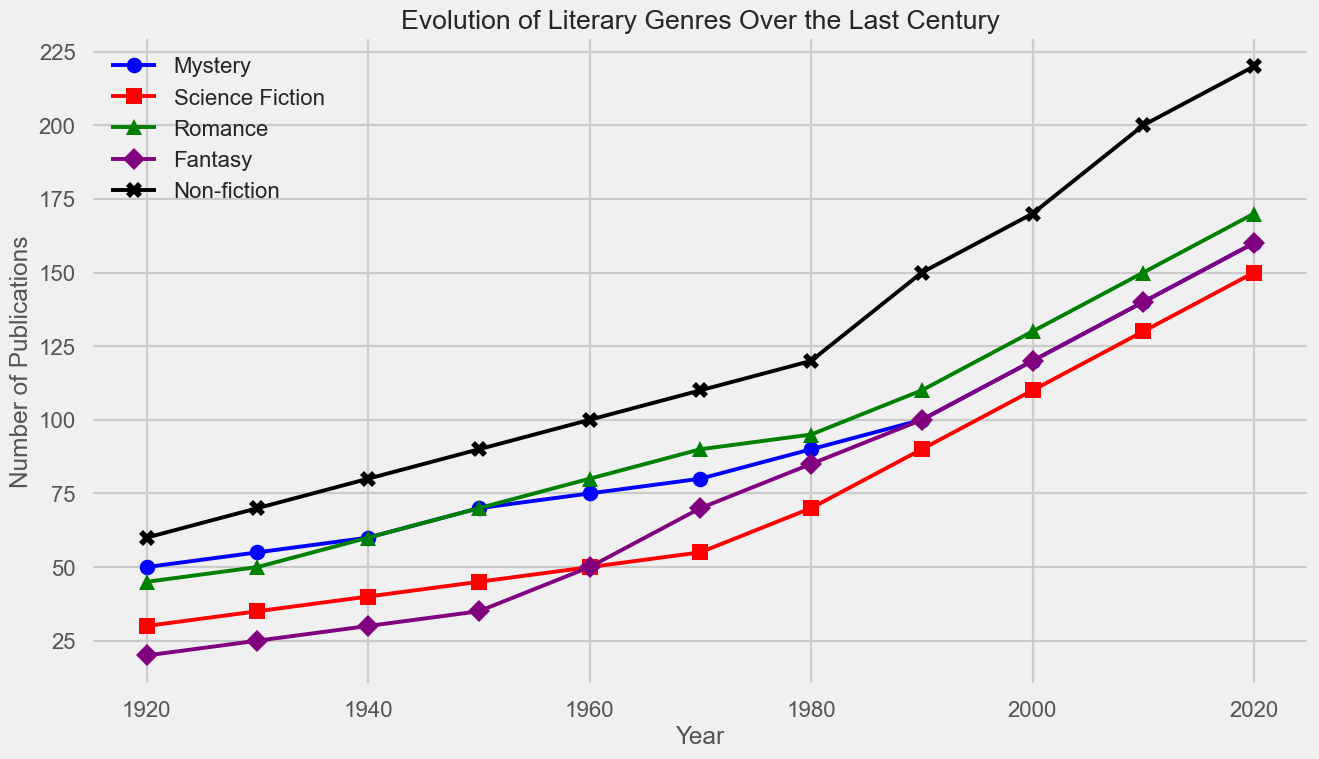what is the overall trend of Romance publications over the years? The green line with triangle markers representing Romance shows a steady increase from 45 publications in 1920 to 170 publications in 2020. This indicates a consistent growth in Romance publications over the century.
Answer: Steady increase Which genre had the highest number of publications in 1940 and how many were there? By observing the year 1940 on the x-axis and comparing the heights of the lines, Non-fiction had the highest number of publications at 80.
Answer: Non-fiction, 80 How did the publications for Science Fiction in 1950 compare to those in 1970? Science Fiction, represented by the red line with square markers, had 45 publications in 1950 and 55 in 1970. The publications increased by 10 over this period.
Answer: Increased by 10 What is the percentage increase in Fantasy publications from 1960 to 2020? In 1960, Fantasy publications were at 50 (purple line with diamond markers), and in 2020, they were at 160. The percentage increase is calculated as: ((160 - 50) / 50) * 100 = 220%.
Answer: 220% Compare the number of Mystery and Romance publications in 1980. Which one is higher and by how much? Mystery (blue line with circle markers) had 90 publications, while Romance (green line with triangle markers) had 95 publications. Romance is higher by 5.
Answer: Romance, by 5 Among all genres, which one showed the most significant growth from 1920 to 2020? By examining the lines' endpoints from 1920 to 2020, Non-fiction (black line with X markers) grew from 60 to 220 publications. The increase of 160 is the most significant growth among all genres.
Answer: Non-fiction What is the average number of publications for Fantasy across the entire timeframe? Summing the Fantasy publications from 1920 to 2020: 20+25+30+35+50+70+85+100+120+140+160 = 835. There are 11 data points, so the average is 835 / 11 ≈ 75.91.
Answer: 75.91 In which decade did Science Fiction first surpass 100 publications? The red line (Science Fiction) first goes above 100 in the 1990s, where it reaches 110 publications in 1990.
Answer: 1990s If you look at the trends, which genres appear to have started growing rapidly around the 1950s? By observing the steepness of the lines, both Romance (green) and Fantasy (purple) began a noticeable rapid growth phase around the 1950s onward.
Answer: Romance and Fantasy Which year shows the smallest difference in publications between Science Fiction and Non-fiction? The smallest difference appears to occur in 1940: Science Fiction (40) and Non-fiction (80), with a difference of 40. Detailed comparison for other years confirms this as the smallest gap.
Answer: 1940 